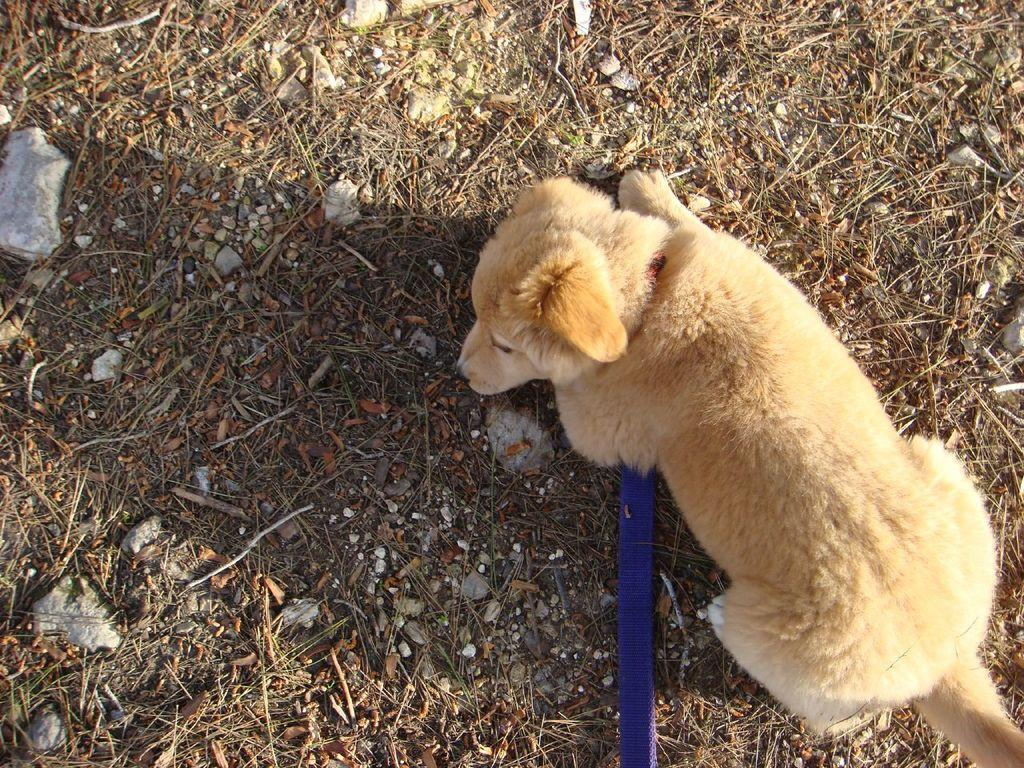What type of animal is in the image? There is a dog in the image. What color is the dog's leash? The dog's leash is in blue color. What can be seen in the background of the image? There are stones, dry leaves, and twigs visible in the background of the image. What type of fruit is the dog offering to the person in the image? There is no fruit or person present in the image; it only features a dog with a blue leash and a background with stones, dry leaves, and twigs. 